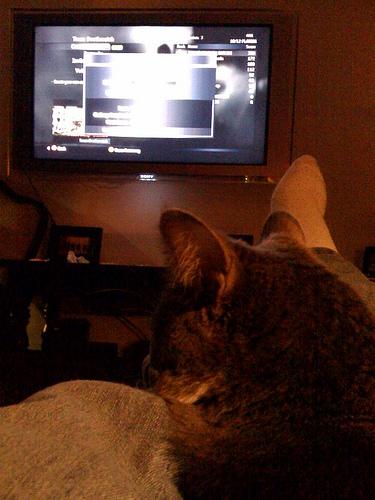Is the person wearing shoes?
Short answer required. No. Is the TV fastened to the wall?
Keep it brief. Yes. Is the cat watching TV?
Concise answer only. No. 